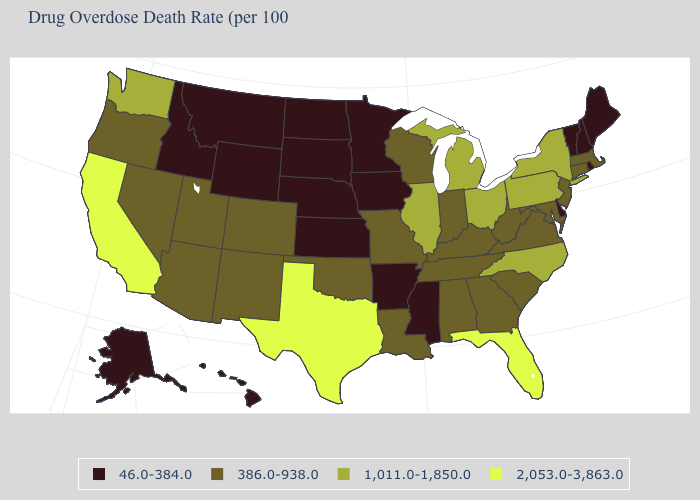What is the value of Vermont?
Keep it brief. 46.0-384.0. Name the states that have a value in the range 386.0-938.0?
Be succinct. Alabama, Arizona, Colorado, Connecticut, Georgia, Indiana, Kentucky, Louisiana, Maryland, Massachusetts, Missouri, Nevada, New Jersey, New Mexico, Oklahoma, Oregon, South Carolina, Tennessee, Utah, Virginia, West Virginia, Wisconsin. Is the legend a continuous bar?
Keep it brief. No. Does the first symbol in the legend represent the smallest category?
Be succinct. Yes. Name the states that have a value in the range 46.0-384.0?
Quick response, please. Alaska, Arkansas, Delaware, Hawaii, Idaho, Iowa, Kansas, Maine, Minnesota, Mississippi, Montana, Nebraska, New Hampshire, North Dakota, Rhode Island, South Dakota, Vermont, Wyoming. What is the value of Louisiana?
Concise answer only. 386.0-938.0. Is the legend a continuous bar?
Answer briefly. No. What is the lowest value in states that border Delaware?
Be succinct. 386.0-938.0. Does the map have missing data?
Answer briefly. No. What is the lowest value in the USA?
Short answer required. 46.0-384.0. Among the states that border Vermont , does Massachusetts have the lowest value?
Quick response, please. No. What is the lowest value in the USA?
Write a very short answer. 46.0-384.0. Does the first symbol in the legend represent the smallest category?
Quick response, please. Yes. Does the map have missing data?
Keep it brief. No. 